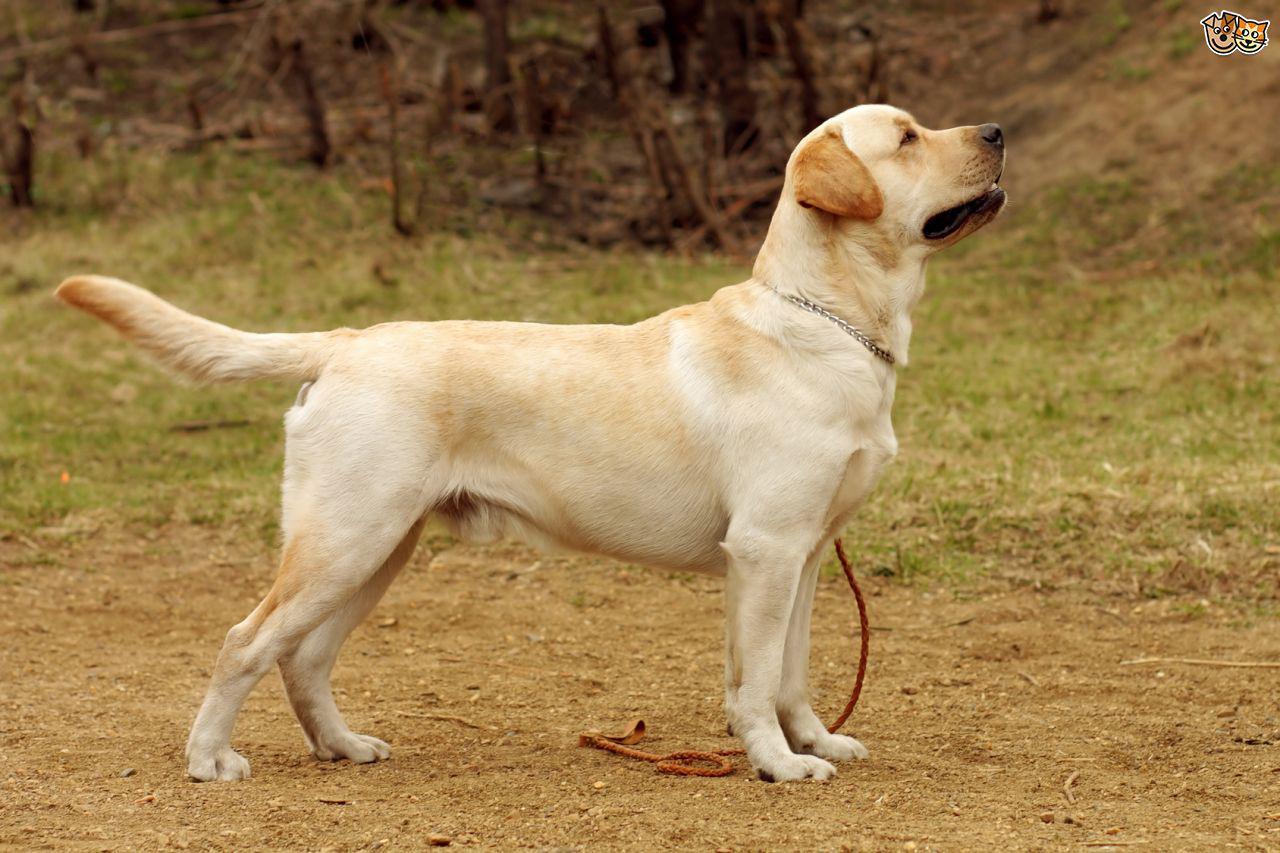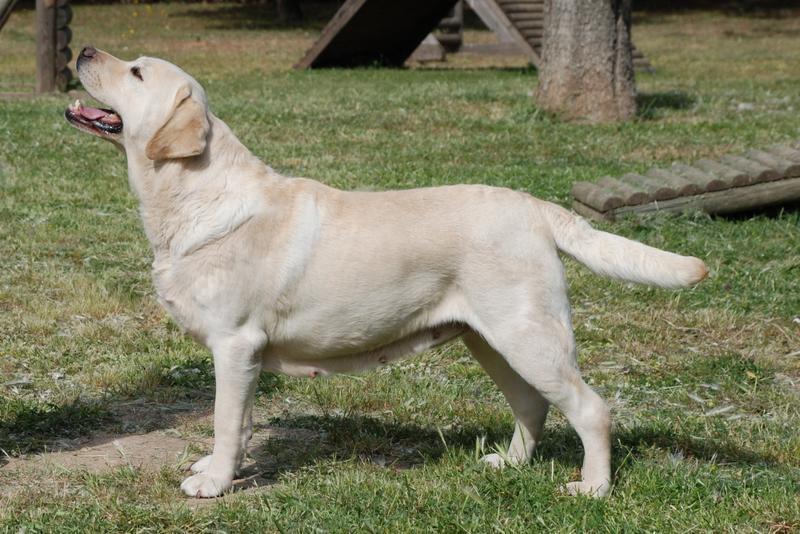The first image is the image on the left, the second image is the image on the right. Evaluate the accuracy of this statement regarding the images: "There is one black dog". Is it true? Answer yes or no. No. 